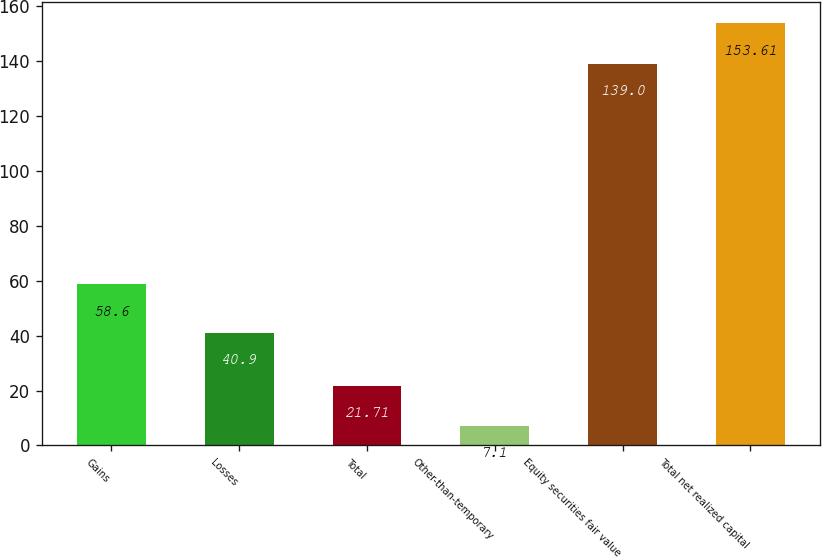<chart> <loc_0><loc_0><loc_500><loc_500><bar_chart><fcel>Gains<fcel>Losses<fcel>Total<fcel>Other-than-temporary<fcel>Equity securities fair value<fcel>Total net realized capital<nl><fcel>58.6<fcel>40.9<fcel>21.71<fcel>7.1<fcel>139<fcel>153.61<nl></chart> 